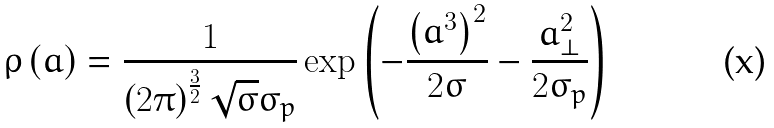Convert formula to latex. <formula><loc_0><loc_0><loc_500><loc_500>\rho \left ( { a } \right ) = \frac { 1 } { { \left ( { 2 \pi } \right ) ^ { \frac { 3 } { 2 } } \sqrt { \sigma } \sigma _ { p } } } \exp \left ( { - \frac { { \left ( { a ^ { 3 } } \right ) ^ { 2 } } } { 2 \sigma } - \frac { { { a } _ { \bot } ^ { 2 } } } { 2 \sigma _ { p } } } \right )</formula> 